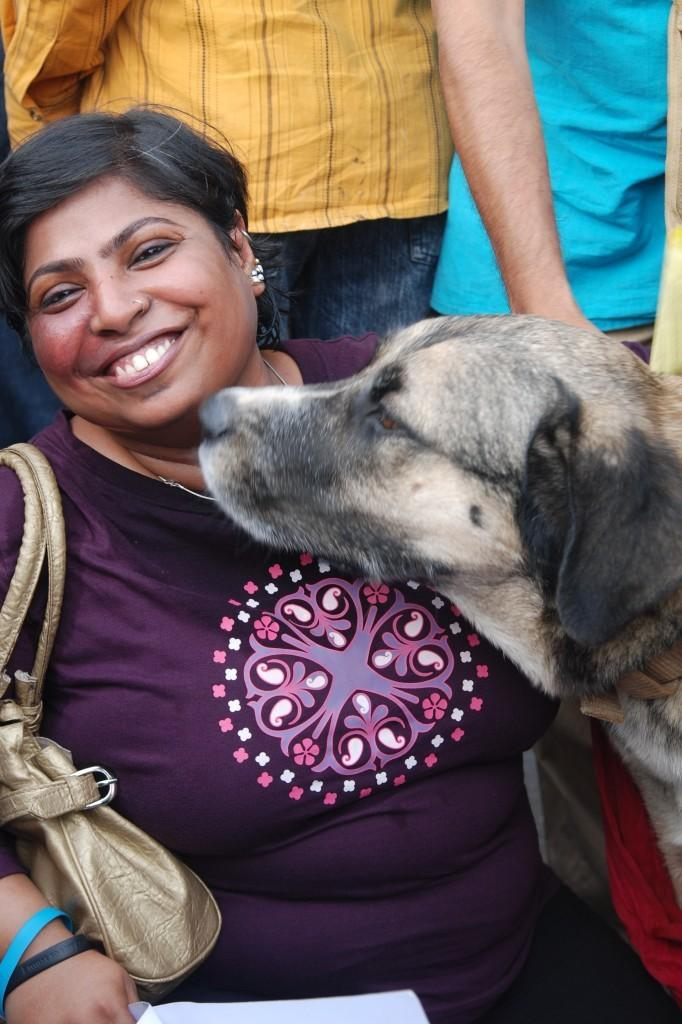Who is on the left side of the image? There is a woman on the left side of the image. What is the woman doing in the image? The woman is smiling in the image. What is on the right side of the image? There is a dog on the right side of the image. Can you describe the people in the background of the image? There are people standing in the background of the image. What type of coach can be seen in the image? There is no coach present in the image. How many trains are visible in the image? There are no trains visible in the image. 